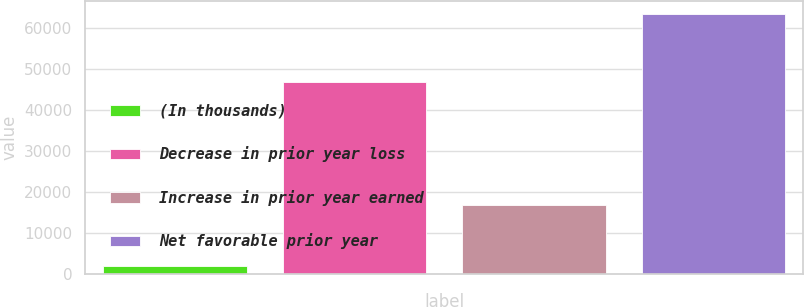Convert chart. <chart><loc_0><loc_0><loc_500><loc_500><bar_chart><fcel>(In thousands)<fcel>Decrease in prior year loss<fcel>Increase in prior year earned<fcel>Net favorable prior year<nl><fcel>2015<fcel>46713<fcel>16730<fcel>63443<nl></chart> 